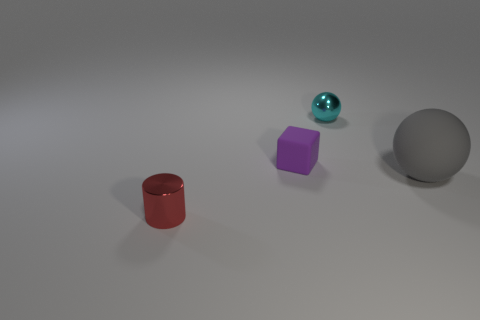Are there any other things that have the same shape as the purple rubber thing?
Provide a short and direct response. No. How many rubber things have the same color as the large matte sphere?
Offer a very short reply. 0. There is a ball that is behind the rubber thing that is to the left of the large rubber sphere; what is its material?
Keep it short and to the point. Metal. The cyan shiny ball has what size?
Your answer should be compact. Small. What number of balls have the same size as the block?
Your answer should be compact. 1. What number of tiny cyan objects are the same shape as the gray object?
Give a very brief answer. 1. Is the number of tiny metal objects in front of the gray ball the same as the number of purple rubber objects?
Offer a very short reply. Yes. Are there any other things that are the same size as the cyan shiny sphere?
Offer a terse response. Yes. What shape is the purple matte object that is the same size as the cyan shiny ball?
Your answer should be compact. Cube. Are there any small objects of the same shape as the large gray matte object?
Provide a short and direct response. Yes. 